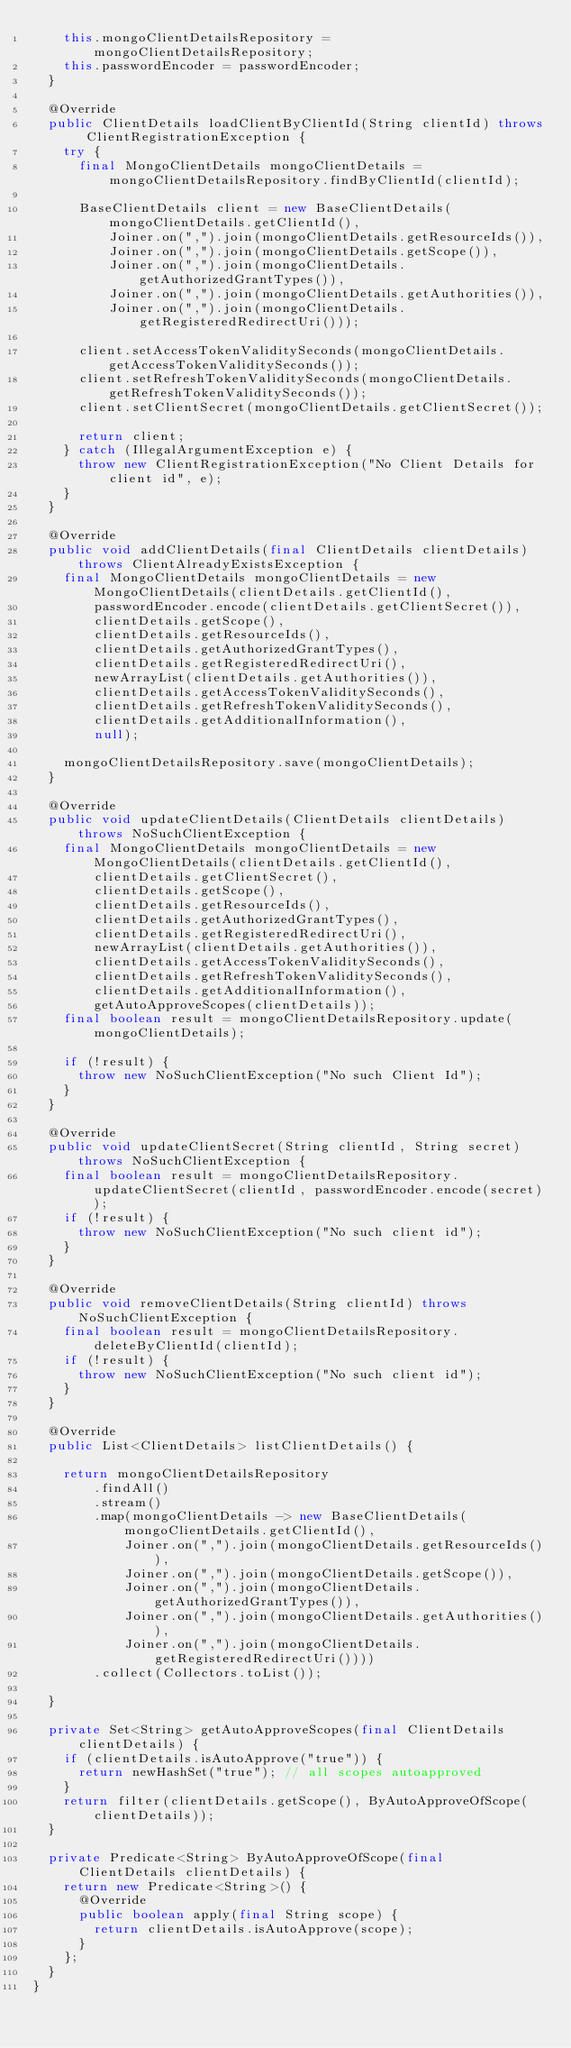Convert code to text. <code><loc_0><loc_0><loc_500><loc_500><_Java_>		this.mongoClientDetailsRepository = mongoClientDetailsRepository;
		this.passwordEncoder = passwordEncoder;
	}

	@Override
	public ClientDetails loadClientByClientId(String clientId) throws ClientRegistrationException {
		try {
			final MongoClientDetails mongoClientDetails = mongoClientDetailsRepository.findByClientId(clientId);

			BaseClientDetails client = new BaseClientDetails(mongoClientDetails.getClientId(),
					Joiner.on(",").join(mongoClientDetails.getResourceIds()),
					Joiner.on(",").join(mongoClientDetails.getScope()),
					Joiner.on(",").join(mongoClientDetails.getAuthorizedGrantTypes()),
					Joiner.on(",").join(mongoClientDetails.getAuthorities()),
					Joiner.on(",").join(mongoClientDetails.getRegisteredRedirectUri()));

			client.setAccessTokenValiditySeconds(mongoClientDetails.getAccessTokenValiditySeconds());
			client.setRefreshTokenValiditySeconds(mongoClientDetails.getRefreshTokenValiditySeconds());
			client.setClientSecret(mongoClientDetails.getClientSecret());
			
			return client;
		} catch (IllegalArgumentException e) {
			throw new ClientRegistrationException("No Client Details for client id", e);
		}
	}

	@Override
	public void addClientDetails(final ClientDetails clientDetails) throws ClientAlreadyExistsException {
		final MongoClientDetails mongoClientDetails = new MongoClientDetails(clientDetails.getClientId(),
				passwordEncoder.encode(clientDetails.getClientSecret()),
				clientDetails.getScope(),
				clientDetails.getResourceIds(),
				clientDetails.getAuthorizedGrantTypes(),
				clientDetails.getRegisteredRedirectUri(),
				newArrayList(clientDetails.getAuthorities()),
				clientDetails.getAccessTokenValiditySeconds(),
				clientDetails.getRefreshTokenValiditySeconds(),
				clientDetails.getAdditionalInformation(),
				null);

		mongoClientDetailsRepository.save(mongoClientDetails);
	}

	@Override
	public void updateClientDetails(ClientDetails clientDetails) throws NoSuchClientException {
		final MongoClientDetails mongoClientDetails = new MongoClientDetails(clientDetails.getClientId(),
				clientDetails.getClientSecret(),
				clientDetails.getScope(),
				clientDetails.getResourceIds(),
				clientDetails.getAuthorizedGrantTypes(),
				clientDetails.getRegisteredRedirectUri(),
				newArrayList(clientDetails.getAuthorities()),
				clientDetails.getAccessTokenValiditySeconds(),
				clientDetails.getRefreshTokenValiditySeconds(),
				clientDetails.getAdditionalInformation(),
				getAutoApproveScopes(clientDetails));
		final boolean result = mongoClientDetailsRepository.update(mongoClientDetails);

		if (!result) {
			throw new NoSuchClientException("No such Client Id");
		}
	}

	@Override
	public void updateClientSecret(String clientId, String secret) throws NoSuchClientException {
		final boolean result = mongoClientDetailsRepository.updateClientSecret(clientId, passwordEncoder.encode(secret));
		if (!result) {
			throw new NoSuchClientException("No such client id");
		}
	}

	@Override
	public void removeClientDetails(String clientId) throws NoSuchClientException {
		final boolean result = mongoClientDetailsRepository.deleteByClientId(clientId);
		if (!result) {
			throw new NoSuchClientException("No such client id");
		}
	}

	@Override
	public List<ClientDetails> listClientDetails() {

		return mongoClientDetailsRepository
				.findAll()
				.stream()
				.map(mongoClientDetails -> new BaseClientDetails(mongoClientDetails.getClientId(),
						Joiner.on(",").join(mongoClientDetails.getResourceIds()),
						Joiner.on(",").join(mongoClientDetails.getScope()),
						Joiner.on(",").join(mongoClientDetails.getAuthorizedGrantTypes()),
						Joiner.on(",").join(mongoClientDetails.getAuthorities()),
						Joiner.on(",").join(mongoClientDetails.getRegisteredRedirectUri())))
				.collect(Collectors.toList());

	}

	private Set<String> getAutoApproveScopes(final ClientDetails clientDetails) {
		if (clientDetails.isAutoApprove("true")) {
			return newHashSet("true"); // all scopes autoapproved
		}
		return filter(clientDetails.getScope(), ByAutoApproveOfScope(clientDetails));
	}

	private Predicate<String> ByAutoApproveOfScope(final ClientDetails clientDetails) {
		return new Predicate<String>() {
			@Override
			public boolean apply(final String scope) {
				return clientDetails.isAutoApprove(scope);
			}
		};
	}
}
</code> 